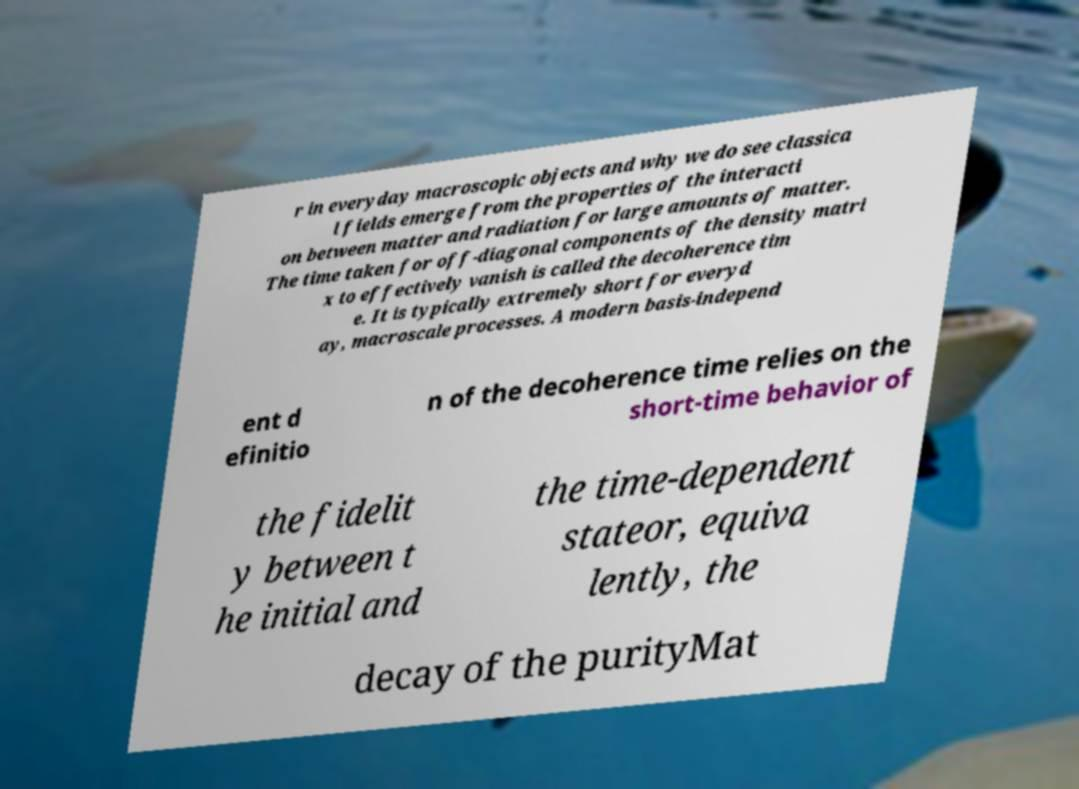There's text embedded in this image that I need extracted. Can you transcribe it verbatim? r in everyday macroscopic objects and why we do see classica l fields emerge from the properties of the interacti on between matter and radiation for large amounts of matter. The time taken for off-diagonal components of the density matri x to effectively vanish is called the decoherence tim e. It is typically extremely short for everyd ay, macroscale processes. A modern basis-independ ent d efinitio n of the decoherence time relies on the short-time behavior of the fidelit y between t he initial and the time-dependent stateor, equiva lently, the decay of the purityMat 